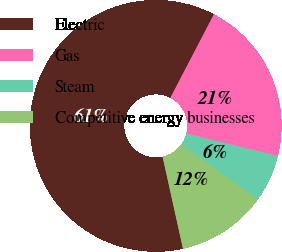Convert chart. <chart><loc_0><loc_0><loc_500><loc_500><pie_chart><fcel>Electric<fcel>Gas<fcel>Steam<fcel>Competitive energy businesses<nl><fcel>61.12%<fcel>21.2%<fcel>6.09%<fcel>11.59%<nl></chart> 